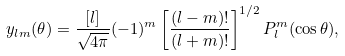<formula> <loc_0><loc_0><loc_500><loc_500>y _ { l m } ( \theta ) = \frac { [ l ] } { \sqrt { 4 \pi } } ( - 1 ) ^ { m } \left [ \frac { ( l - m ) ! } { ( l + m ) ! } \right ] ^ { 1 / 2 } P _ { l } ^ { m } ( \cos \theta ) ,</formula> 